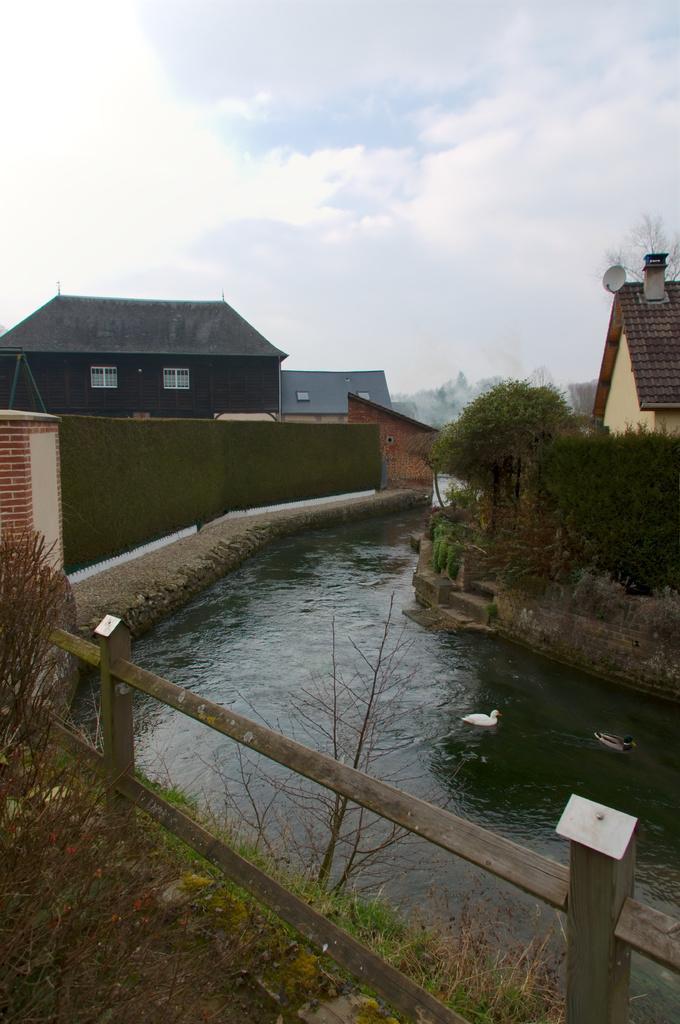Describe this image in one or two sentences. In the middle of the picture, we see water and ducks are swimming in the water. Beside that, we see a wooden railing. At the bottom of the picture, we see grass and trees. On the right side, we see shrubs and a building with a red color roof. On the left side, we see a wall in green color and behind that, we see buildings in black and grey color. At the top of the picture, we see the sky. 